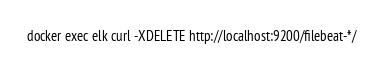<code> <loc_0><loc_0><loc_500><loc_500><_Bash_>docker exec elk curl -XDELETE http://localhost:9200/filebeat-*/
</code> 